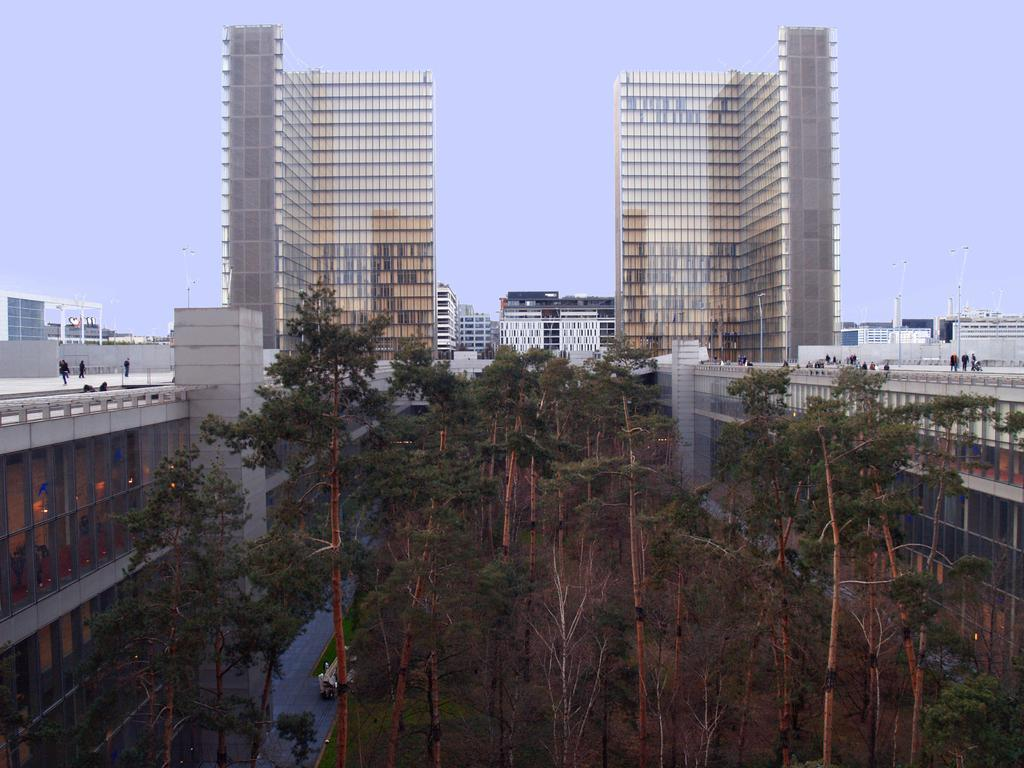What type of natural elements can be seen in the image? There are trees in the image. What type of man-made structures are present in the image? There are buildings and skyscrapers in the image. What is visible in the background of the image? The sky is visible in the image. What are the people in the image doing? The people are standing on the buildings. What type of gate can be seen in the image? There is no gate present in the image. What type of bean is growing on the trees in the image? There are no beans growing on the trees in the image; it features trees and buildings. 